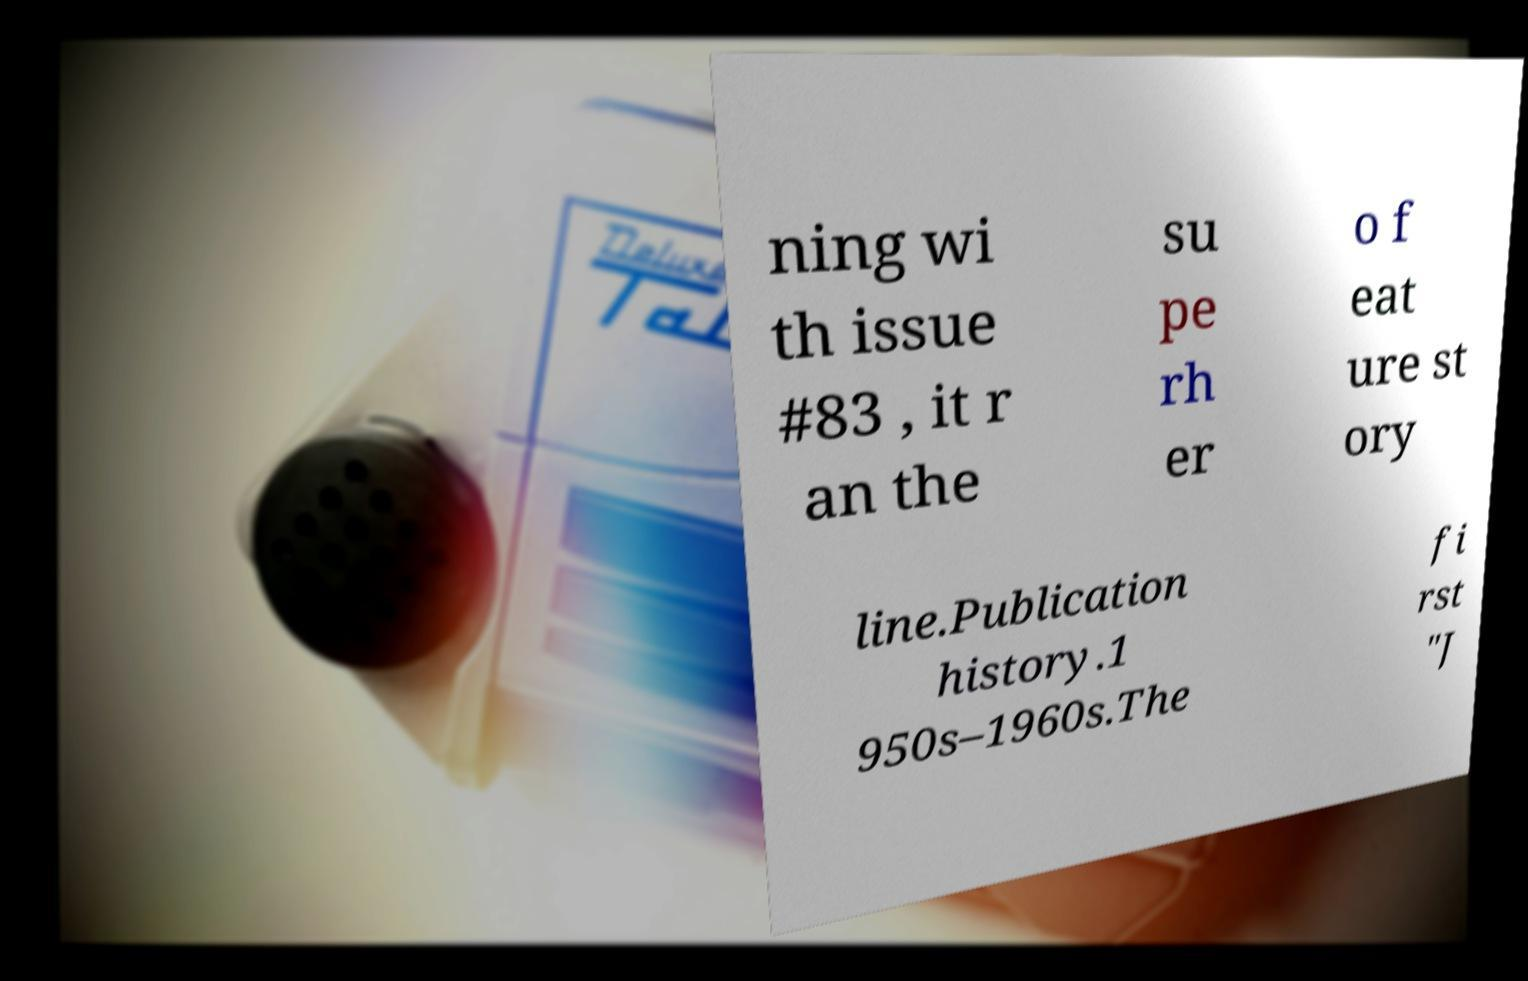For documentation purposes, I need the text within this image transcribed. Could you provide that? ning wi th issue #83 , it r an the su pe rh er o f eat ure st ory line.Publication history.1 950s–1960s.The fi rst "J 